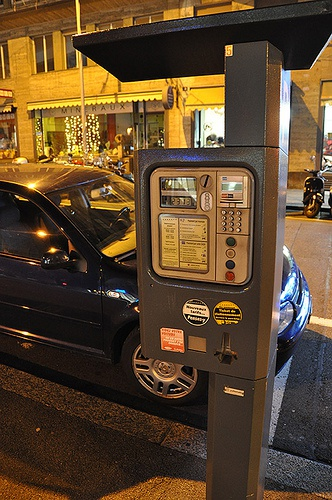Describe the objects in this image and their specific colors. I can see parking meter in maroon, black, and olive tones, car in maroon, black, brown, and orange tones, and motorcycle in maroon, black, and olive tones in this image. 